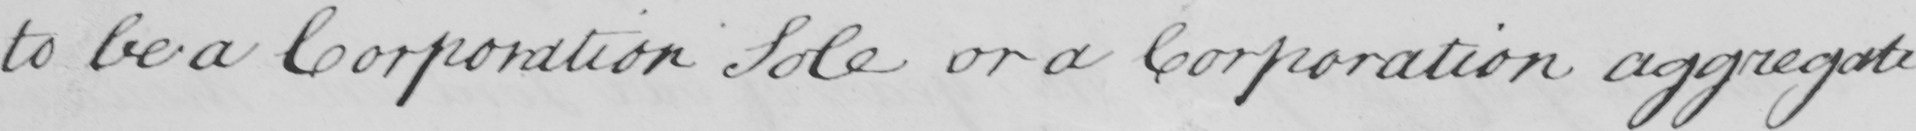Can you read and transcribe this handwriting? to be a Corporation Sole or a Corporation aggregate 